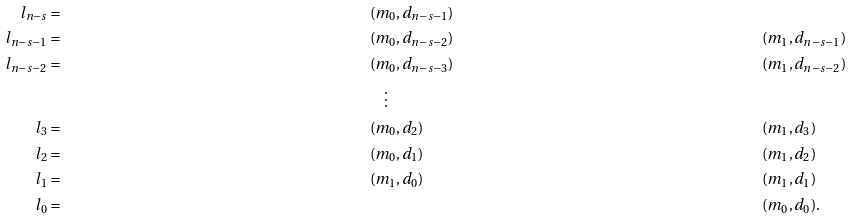Convert formula to latex. <formula><loc_0><loc_0><loc_500><loc_500>l _ { n - s } & = & & ( m _ { 0 } , d _ { n - s - 1 } ) & & \\ l _ { n - s - 1 } & = & & ( m _ { 0 } , d _ { n - s - 2 } ) & & ( m _ { 1 } , d _ { n - s - 1 } ) \\ l _ { n - s - 2 } & = & & ( m _ { 0 } , d _ { n - s - 3 } ) & & ( m _ { 1 } , d _ { n - s - 2 } ) \\ & & & \quad \vdots & & \\ l _ { 3 } & = & & ( m _ { 0 } , d _ { 2 } ) & & ( m _ { 1 } , d _ { 3 } ) \\ l _ { 2 } & = & & ( m _ { 0 } , d _ { 1 } ) & & ( m _ { 1 } , d _ { 2 } ) \\ l _ { 1 } & = & & ( m _ { 1 } , d _ { 0 } ) & & ( m _ { 1 } , d _ { 1 } ) \\ l _ { 0 } & = & & & & ( m _ { 0 } , d _ { 0 } ) .</formula> 